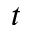Convert formula to latex. <formula><loc_0><loc_0><loc_500><loc_500>t</formula> 